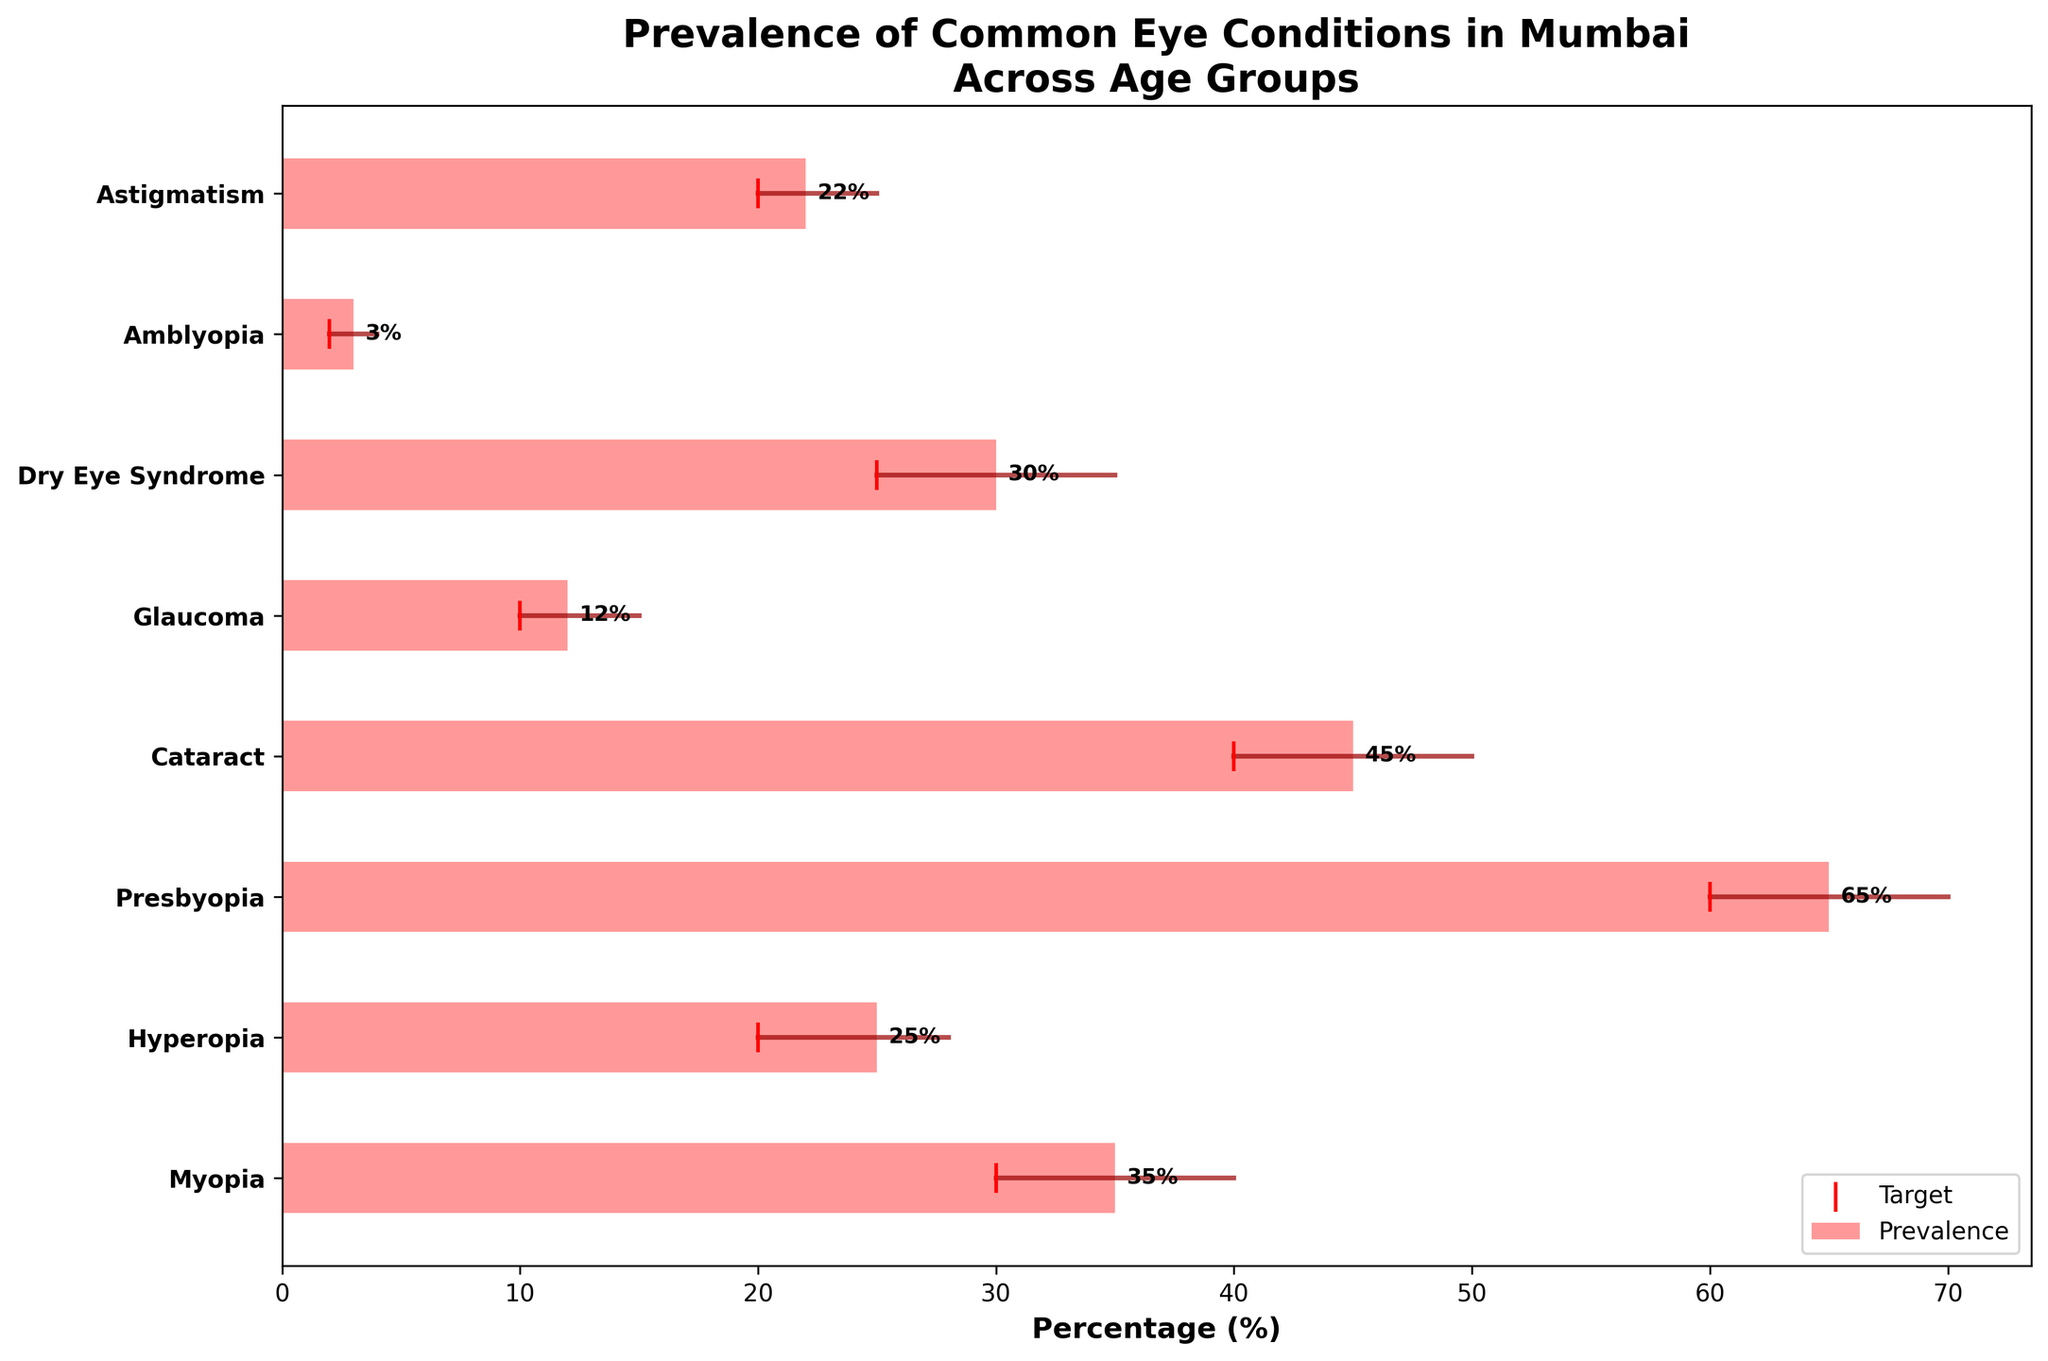What is the title of the chart? The title is usually displayed prominently at the top of a figure. Looking at the figure, the title is "Prevalence of Common Eye Conditions in Mumbai Across Age Groups".
Answer: Prevalence of Common Eye Conditions in Mumbai Across Age Groups Which eye condition has the highest prevalence? To determine the highest prevalence, compare the bars representing prevalence. The longest bar represents Presbyopia in the Middle-aged group (41-60) with 65%.
Answer: Presbyopia What is the target percentage for Myopia in children? Targets are marked with red vertical lines next to each condition. For Myopia in children, the target line is located at 30%.
Answer: 30% How many eye conditions are reported for seniors (61+)? Examine the y-axis labels for age groups. The conditions listed under "Seniors (61+)" are Cataract and Glaucoma.
Answer: 2 What is the difference between the prevalence and the target for Hyperopia in adults? Hyperopia's prevalence for adults (18-40) is 25% and the target is 20%. The difference is 25% - 20% = 5%.
Answer: 5% Which age group has the highest target percentage for any eye condition? Evaluate the red target markers. The highest target percentage is for Presbyopia in Middle-aged (41-60) at 60%.
Answer: Middle-aged (41-60) How is the comparison range visually represented in the chart? The comparison range is depicted by horizontal lines connecting the target with the endpoint of the comparison range.
Answer: Horizontal lines Which condition has a comparison range that does not overlap with its target percentage? Analyze the lines connecting targets and comparison percentages. For Amblyopia in children, the range 2% - 4% does not overlap with the target of 2%, as the prevalence is 3%.
Answer: Amblyopia Which eye condition has the closest prevalence percentage to its target? Compare the bars and red lines. Dry Eye Syndrome in adults (18-40) has a prevalence of 30% and a target of 25%, making a small difference of 5%.
Answer: Dry Eye Syndrome What is the average prevalence percentage for the conditions listed? Sum all the prevalence percentages and divide by the number of conditions: (35 + 25 + 65 + 45 + 12 + 30 + 3 + 22) / 8 = 29.625%.
Answer: 29.625% 